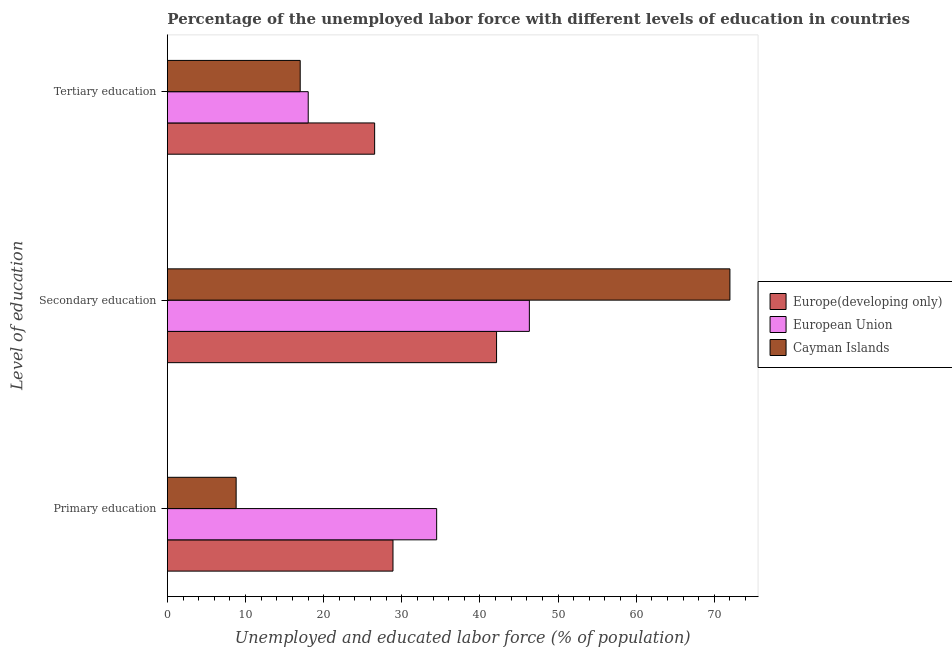How many different coloured bars are there?
Keep it short and to the point. 3. How many groups of bars are there?
Ensure brevity in your answer.  3. Are the number of bars per tick equal to the number of legend labels?
Ensure brevity in your answer.  Yes. What is the label of the 1st group of bars from the top?
Provide a short and direct response. Tertiary education. What is the percentage of labor force who received secondary education in Europe(developing only)?
Keep it short and to the point. 42.13. Across all countries, what is the maximum percentage of labor force who received tertiary education?
Provide a succinct answer. 26.53. Across all countries, what is the minimum percentage of labor force who received primary education?
Your response must be concise. 8.8. In which country was the percentage of labor force who received tertiary education maximum?
Offer a terse response. Europe(developing only). In which country was the percentage of labor force who received secondary education minimum?
Your answer should be very brief. Europe(developing only). What is the total percentage of labor force who received tertiary education in the graph?
Ensure brevity in your answer.  61.55. What is the difference between the percentage of labor force who received secondary education in European Union and that in Cayman Islands?
Offer a terse response. -25.67. What is the difference between the percentage of labor force who received primary education in European Union and the percentage of labor force who received secondary education in Cayman Islands?
Your response must be concise. -37.54. What is the average percentage of labor force who received primary education per country?
Give a very brief answer. 24.05. What is the difference between the percentage of labor force who received secondary education and percentage of labor force who received primary education in European Union?
Your answer should be compact. 11.86. What is the ratio of the percentage of labor force who received secondary education in Europe(developing only) to that in Cayman Islands?
Your answer should be very brief. 0.59. Is the difference between the percentage of labor force who received secondary education in European Union and Europe(developing only) greater than the difference between the percentage of labor force who received primary education in European Union and Europe(developing only)?
Your answer should be very brief. No. What is the difference between the highest and the second highest percentage of labor force who received primary education?
Provide a short and direct response. 5.59. What is the difference between the highest and the lowest percentage of labor force who received tertiary education?
Give a very brief answer. 9.53. What does the 1st bar from the top in Secondary education represents?
Give a very brief answer. Cayman Islands. What does the 2nd bar from the bottom in Primary education represents?
Provide a short and direct response. European Union. Is it the case that in every country, the sum of the percentage of labor force who received primary education and percentage of labor force who received secondary education is greater than the percentage of labor force who received tertiary education?
Offer a very short reply. Yes. How many bars are there?
Your answer should be very brief. 9. Are all the bars in the graph horizontal?
Your response must be concise. Yes. How many countries are there in the graph?
Provide a succinct answer. 3. What is the difference between two consecutive major ticks on the X-axis?
Provide a succinct answer. 10. Does the graph contain any zero values?
Provide a succinct answer. No. How many legend labels are there?
Offer a terse response. 3. How are the legend labels stacked?
Give a very brief answer. Vertical. What is the title of the graph?
Offer a very short reply. Percentage of the unemployed labor force with different levels of education in countries. What is the label or title of the X-axis?
Ensure brevity in your answer.  Unemployed and educated labor force (% of population). What is the label or title of the Y-axis?
Ensure brevity in your answer.  Level of education. What is the Unemployed and educated labor force (% of population) in Europe(developing only) in Primary education?
Provide a short and direct response. 28.87. What is the Unemployed and educated labor force (% of population) of European Union in Primary education?
Offer a terse response. 34.46. What is the Unemployed and educated labor force (% of population) in Cayman Islands in Primary education?
Offer a terse response. 8.8. What is the Unemployed and educated labor force (% of population) of Europe(developing only) in Secondary education?
Offer a very short reply. 42.13. What is the Unemployed and educated labor force (% of population) in European Union in Secondary education?
Your response must be concise. 46.33. What is the Unemployed and educated labor force (% of population) in Europe(developing only) in Tertiary education?
Provide a succinct answer. 26.53. What is the Unemployed and educated labor force (% of population) of European Union in Tertiary education?
Your answer should be very brief. 18.02. What is the Unemployed and educated labor force (% of population) in Cayman Islands in Tertiary education?
Offer a terse response. 17. Across all Level of education, what is the maximum Unemployed and educated labor force (% of population) in Europe(developing only)?
Give a very brief answer. 42.13. Across all Level of education, what is the maximum Unemployed and educated labor force (% of population) of European Union?
Offer a very short reply. 46.33. Across all Level of education, what is the minimum Unemployed and educated labor force (% of population) in Europe(developing only)?
Provide a short and direct response. 26.53. Across all Level of education, what is the minimum Unemployed and educated labor force (% of population) of European Union?
Make the answer very short. 18.02. Across all Level of education, what is the minimum Unemployed and educated labor force (% of population) of Cayman Islands?
Keep it short and to the point. 8.8. What is the total Unemployed and educated labor force (% of population) in Europe(developing only) in the graph?
Keep it short and to the point. 97.53. What is the total Unemployed and educated labor force (% of population) in European Union in the graph?
Your answer should be compact. 98.82. What is the total Unemployed and educated labor force (% of population) of Cayman Islands in the graph?
Keep it short and to the point. 97.8. What is the difference between the Unemployed and educated labor force (% of population) in Europe(developing only) in Primary education and that in Secondary education?
Provide a succinct answer. -13.26. What is the difference between the Unemployed and educated labor force (% of population) in European Union in Primary education and that in Secondary education?
Provide a succinct answer. -11.86. What is the difference between the Unemployed and educated labor force (% of population) in Cayman Islands in Primary education and that in Secondary education?
Keep it short and to the point. -63.2. What is the difference between the Unemployed and educated labor force (% of population) of Europe(developing only) in Primary education and that in Tertiary education?
Provide a short and direct response. 2.35. What is the difference between the Unemployed and educated labor force (% of population) in European Union in Primary education and that in Tertiary education?
Your answer should be very brief. 16.44. What is the difference between the Unemployed and educated labor force (% of population) in Europe(developing only) in Secondary education and that in Tertiary education?
Provide a succinct answer. 15.61. What is the difference between the Unemployed and educated labor force (% of population) of European Union in Secondary education and that in Tertiary education?
Offer a very short reply. 28.3. What is the difference between the Unemployed and educated labor force (% of population) of Europe(developing only) in Primary education and the Unemployed and educated labor force (% of population) of European Union in Secondary education?
Your response must be concise. -17.45. What is the difference between the Unemployed and educated labor force (% of population) in Europe(developing only) in Primary education and the Unemployed and educated labor force (% of population) in Cayman Islands in Secondary education?
Your response must be concise. -43.13. What is the difference between the Unemployed and educated labor force (% of population) in European Union in Primary education and the Unemployed and educated labor force (% of population) in Cayman Islands in Secondary education?
Provide a short and direct response. -37.54. What is the difference between the Unemployed and educated labor force (% of population) in Europe(developing only) in Primary education and the Unemployed and educated labor force (% of population) in European Union in Tertiary education?
Your response must be concise. 10.85. What is the difference between the Unemployed and educated labor force (% of population) of Europe(developing only) in Primary education and the Unemployed and educated labor force (% of population) of Cayman Islands in Tertiary education?
Your answer should be very brief. 11.87. What is the difference between the Unemployed and educated labor force (% of population) in European Union in Primary education and the Unemployed and educated labor force (% of population) in Cayman Islands in Tertiary education?
Keep it short and to the point. 17.46. What is the difference between the Unemployed and educated labor force (% of population) of Europe(developing only) in Secondary education and the Unemployed and educated labor force (% of population) of European Union in Tertiary education?
Keep it short and to the point. 24.11. What is the difference between the Unemployed and educated labor force (% of population) of Europe(developing only) in Secondary education and the Unemployed and educated labor force (% of population) of Cayman Islands in Tertiary education?
Make the answer very short. 25.13. What is the difference between the Unemployed and educated labor force (% of population) of European Union in Secondary education and the Unemployed and educated labor force (% of population) of Cayman Islands in Tertiary education?
Make the answer very short. 29.33. What is the average Unemployed and educated labor force (% of population) of Europe(developing only) per Level of education?
Offer a very short reply. 32.51. What is the average Unemployed and educated labor force (% of population) of European Union per Level of education?
Provide a succinct answer. 32.94. What is the average Unemployed and educated labor force (% of population) in Cayman Islands per Level of education?
Offer a terse response. 32.6. What is the difference between the Unemployed and educated labor force (% of population) in Europe(developing only) and Unemployed and educated labor force (% of population) in European Union in Primary education?
Your response must be concise. -5.59. What is the difference between the Unemployed and educated labor force (% of population) of Europe(developing only) and Unemployed and educated labor force (% of population) of Cayman Islands in Primary education?
Keep it short and to the point. 20.07. What is the difference between the Unemployed and educated labor force (% of population) in European Union and Unemployed and educated labor force (% of population) in Cayman Islands in Primary education?
Offer a terse response. 25.66. What is the difference between the Unemployed and educated labor force (% of population) of Europe(developing only) and Unemployed and educated labor force (% of population) of European Union in Secondary education?
Give a very brief answer. -4.2. What is the difference between the Unemployed and educated labor force (% of population) in Europe(developing only) and Unemployed and educated labor force (% of population) in Cayman Islands in Secondary education?
Provide a short and direct response. -29.87. What is the difference between the Unemployed and educated labor force (% of population) in European Union and Unemployed and educated labor force (% of population) in Cayman Islands in Secondary education?
Provide a succinct answer. -25.67. What is the difference between the Unemployed and educated labor force (% of population) of Europe(developing only) and Unemployed and educated labor force (% of population) of European Union in Tertiary education?
Offer a terse response. 8.5. What is the difference between the Unemployed and educated labor force (% of population) of Europe(developing only) and Unemployed and educated labor force (% of population) of Cayman Islands in Tertiary education?
Provide a short and direct response. 9.53. What is the difference between the Unemployed and educated labor force (% of population) in European Union and Unemployed and educated labor force (% of population) in Cayman Islands in Tertiary education?
Provide a short and direct response. 1.02. What is the ratio of the Unemployed and educated labor force (% of population) of Europe(developing only) in Primary education to that in Secondary education?
Provide a succinct answer. 0.69. What is the ratio of the Unemployed and educated labor force (% of population) of European Union in Primary education to that in Secondary education?
Offer a very short reply. 0.74. What is the ratio of the Unemployed and educated labor force (% of population) of Cayman Islands in Primary education to that in Secondary education?
Offer a terse response. 0.12. What is the ratio of the Unemployed and educated labor force (% of population) in Europe(developing only) in Primary education to that in Tertiary education?
Offer a very short reply. 1.09. What is the ratio of the Unemployed and educated labor force (% of population) in European Union in Primary education to that in Tertiary education?
Ensure brevity in your answer.  1.91. What is the ratio of the Unemployed and educated labor force (% of population) in Cayman Islands in Primary education to that in Tertiary education?
Offer a very short reply. 0.52. What is the ratio of the Unemployed and educated labor force (% of population) in Europe(developing only) in Secondary education to that in Tertiary education?
Offer a very short reply. 1.59. What is the ratio of the Unemployed and educated labor force (% of population) in European Union in Secondary education to that in Tertiary education?
Provide a short and direct response. 2.57. What is the ratio of the Unemployed and educated labor force (% of population) of Cayman Islands in Secondary education to that in Tertiary education?
Provide a short and direct response. 4.24. What is the difference between the highest and the second highest Unemployed and educated labor force (% of population) in Europe(developing only)?
Your answer should be very brief. 13.26. What is the difference between the highest and the second highest Unemployed and educated labor force (% of population) in European Union?
Ensure brevity in your answer.  11.86. What is the difference between the highest and the lowest Unemployed and educated labor force (% of population) of Europe(developing only)?
Provide a succinct answer. 15.61. What is the difference between the highest and the lowest Unemployed and educated labor force (% of population) of European Union?
Give a very brief answer. 28.3. What is the difference between the highest and the lowest Unemployed and educated labor force (% of population) in Cayman Islands?
Ensure brevity in your answer.  63.2. 